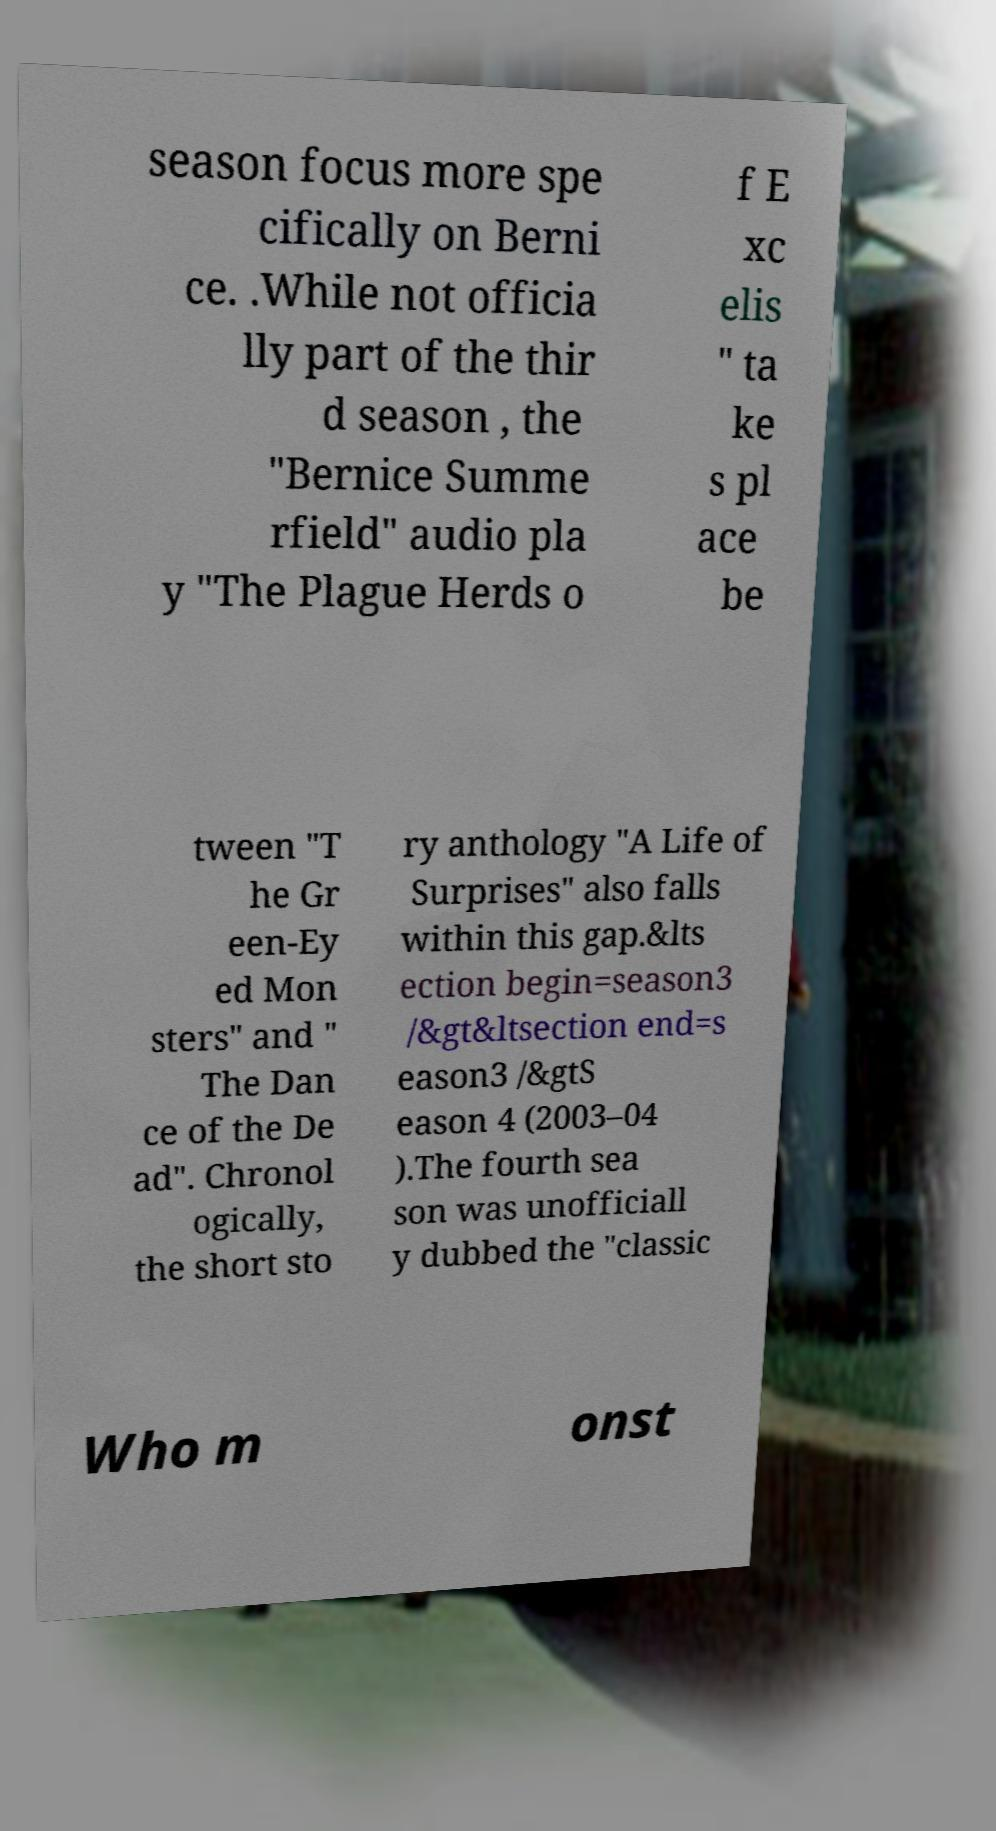I need the written content from this picture converted into text. Can you do that? season focus more spe cifically on Berni ce. .While not officia lly part of the thir d season , the "Bernice Summe rfield" audio pla y "The Plague Herds o f E xc elis " ta ke s pl ace be tween "T he Gr een-Ey ed Mon sters" and " The Dan ce of the De ad". Chronol ogically, the short sto ry anthology "A Life of Surprises" also falls within this gap.&lts ection begin=season3 /&gt&ltsection end=s eason3 /&gtS eason 4 (2003–04 ).The fourth sea son was unofficiall y dubbed the "classic Who m onst 